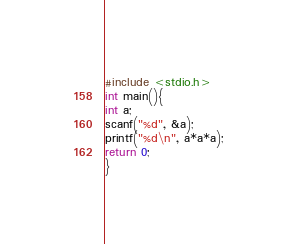<code> <loc_0><loc_0><loc_500><loc_500><_C_>#include <stdio.h>
int main(){
int a;
scanf("%d", &a);
printf("%d\n", a*a*a);
return 0;
}
</code> 